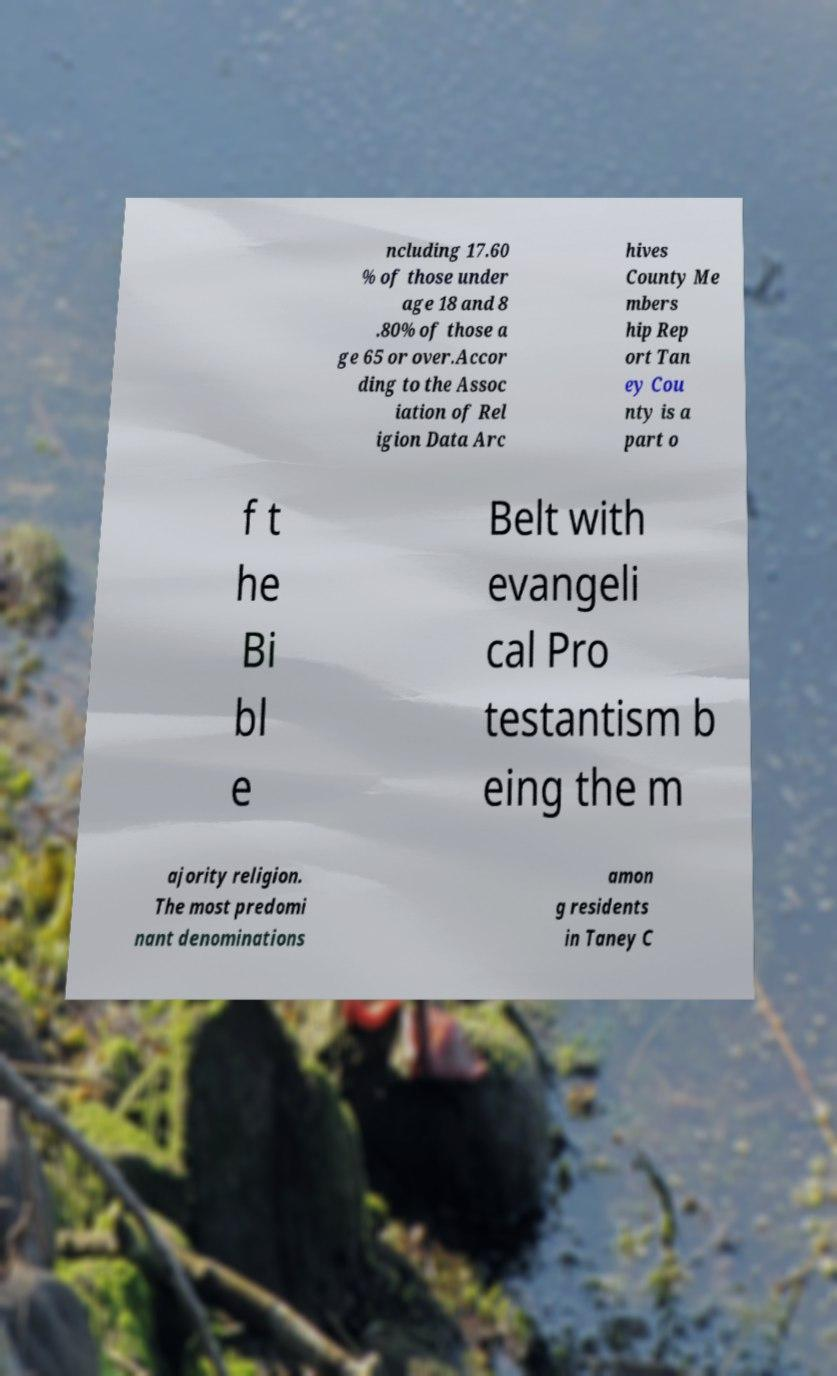Could you extract and type out the text from this image? ncluding 17.60 % of those under age 18 and 8 .80% of those a ge 65 or over.Accor ding to the Assoc iation of Rel igion Data Arc hives County Me mbers hip Rep ort Tan ey Cou nty is a part o f t he Bi bl e Belt with evangeli cal Pro testantism b eing the m ajority religion. The most predomi nant denominations amon g residents in Taney C 